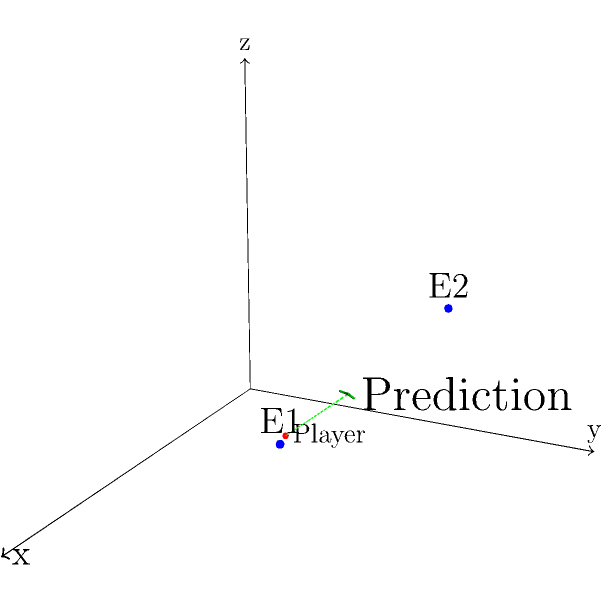In a first-person shooter game, you're at position (1,1,0) and observe two enemies at positions E1(3,2,1) and E2(2,3,2). Assuming they continue moving in a straight line at constant speed, what are the coordinates of their predicted meeting point? To solve this problem, we'll use vector addition and scalar multiplication:

1. Calculate the vector from E1 to E2:
   $\vec{v} = E2 - E1 = (2,3,2) - (3,2,1) = (-1,1,1)$

2. Extend this vector to find the meeting point. Let's call the scalar 't':
   $M = E1 + t\vec{v} = (3,2,1) + t(-1,1,1)$

3. Parametric equations for the meeting point:
   $x = 3 - t$
   $y = 2 + t$
   $z = 1 + t$

4. To find 't', we can use the fact that the x-coordinate decreases by 1, while y and z increase by 1 for each unit of 't'.
   When $t = 1$, $x = 2$, $y = 3$, and $z = 2$
   When $t = 2$, $x = 1$, $y = 4$, and $z = 3$

5. The enemies will meet when $t = 2$, as this is when their movement pattern completes one full cycle.

6. Substituting $t = 2$ into the parametric equations:
   $x = 3 - 2 = 1$
   $y = 2 + 2 = 4$
   $z = 1 + 2 = 3$

Therefore, the predicted meeting point is (1,4,3).
Answer: (1,4,3) 